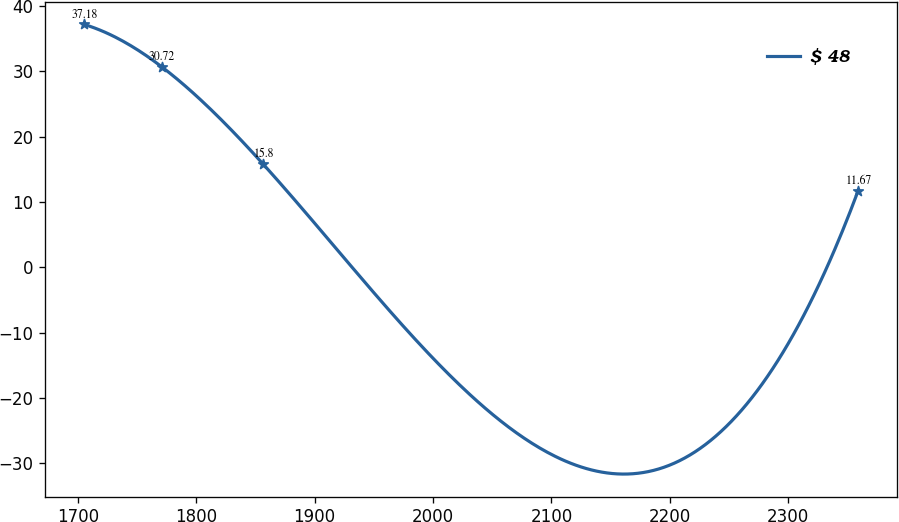Convert chart. <chart><loc_0><loc_0><loc_500><loc_500><line_chart><ecel><fcel>$ 48<nl><fcel>1705.24<fcel>37.18<nl><fcel>1770.62<fcel>30.72<nl><fcel>1856.45<fcel>15.8<nl><fcel>2359<fcel>11.67<nl></chart> 